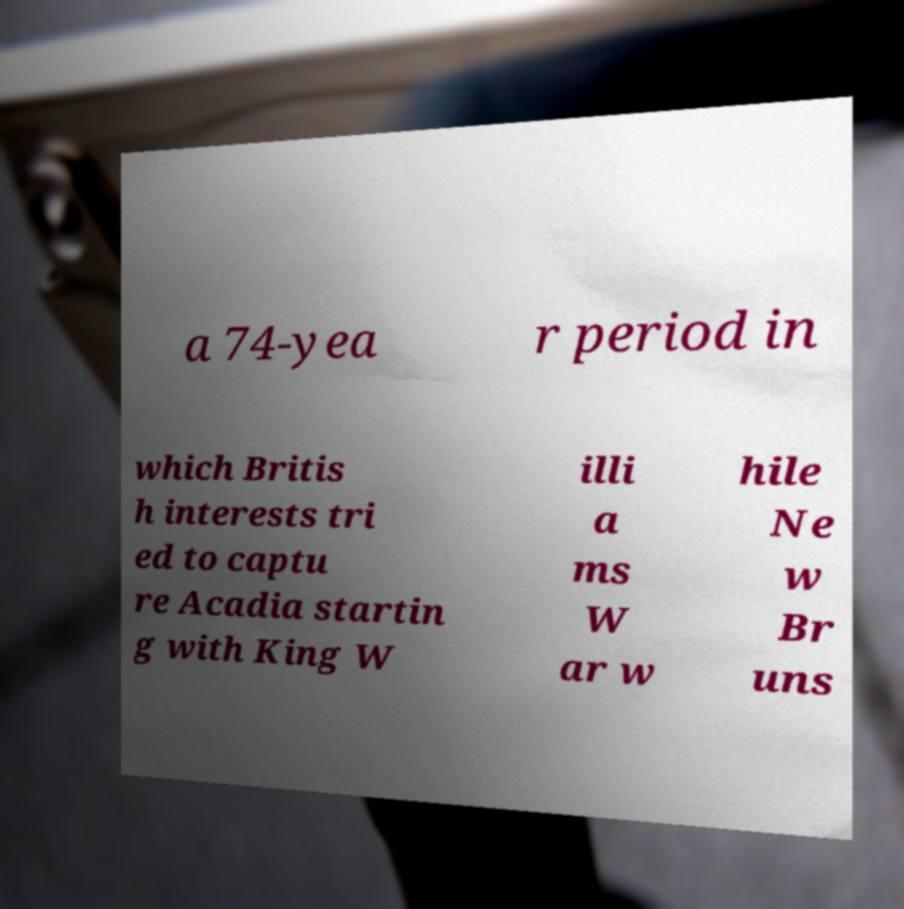Please read and relay the text visible in this image. What does it say? a 74-yea r period in which Britis h interests tri ed to captu re Acadia startin g with King W illi a ms W ar w hile Ne w Br uns 